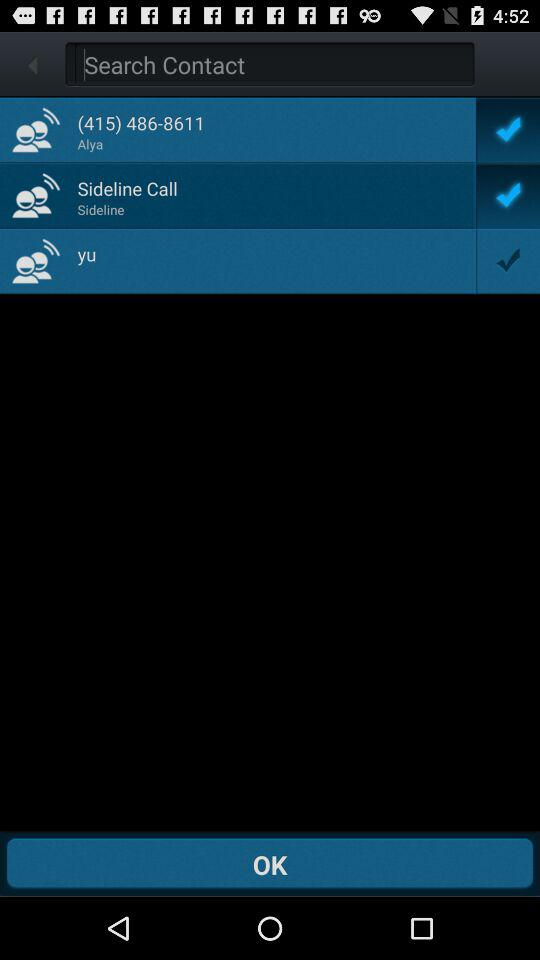What are the selected options? The selected options are "(415) 486-8611" and "Sideline Call". 